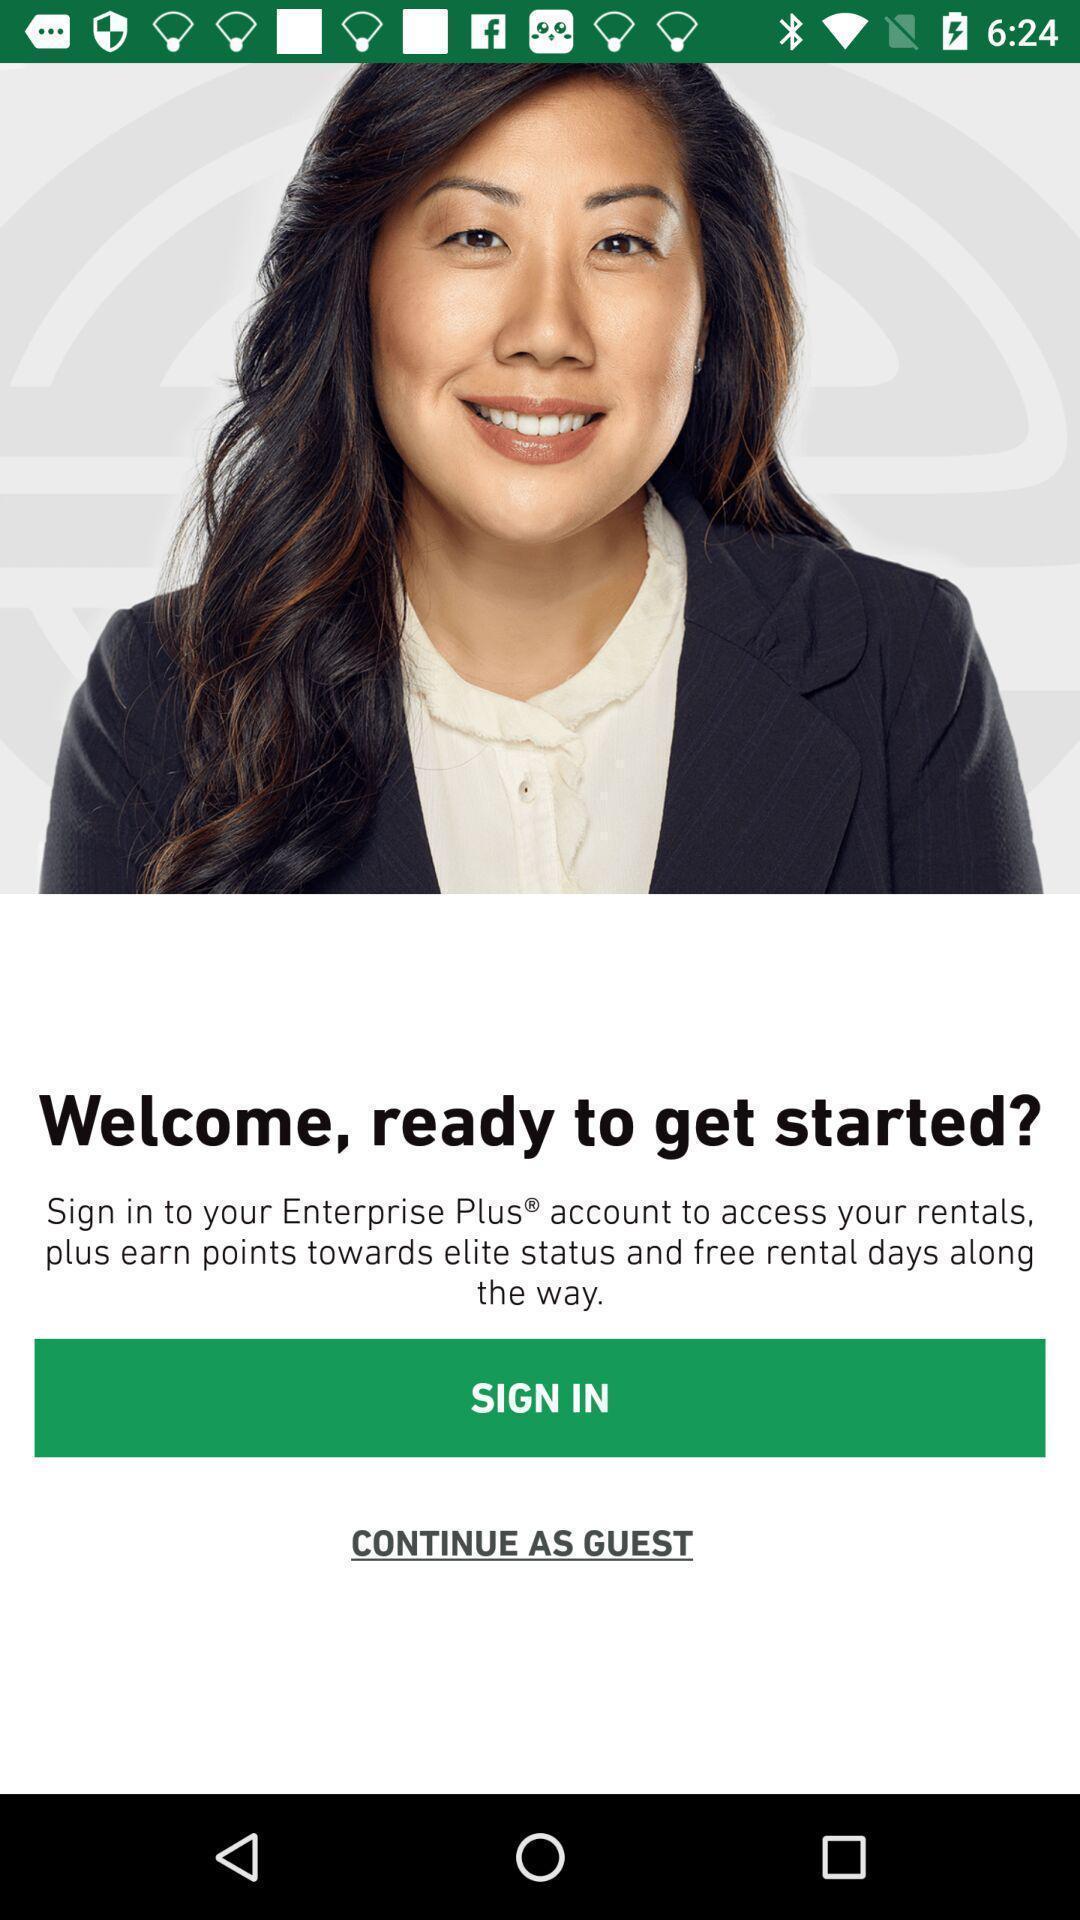Please provide a description for this image. Sign in page. 